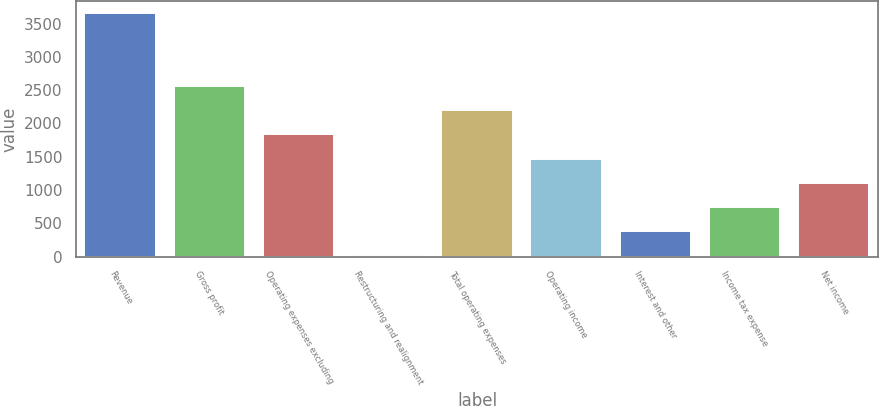Convert chart. <chart><loc_0><loc_0><loc_500><loc_500><bar_chart><fcel>Revenue<fcel>Gross profit<fcel>Operating expenses excluding<fcel>Restructuring and realignment<fcel>Total operating expenses<fcel>Operating income<fcel>Interest and other<fcel>Income tax expense<fcel>Net income<nl><fcel>3653<fcel>2563.1<fcel>1836.5<fcel>20<fcel>2199.8<fcel>1473.2<fcel>383.3<fcel>746.6<fcel>1109.9<nl></chart> 